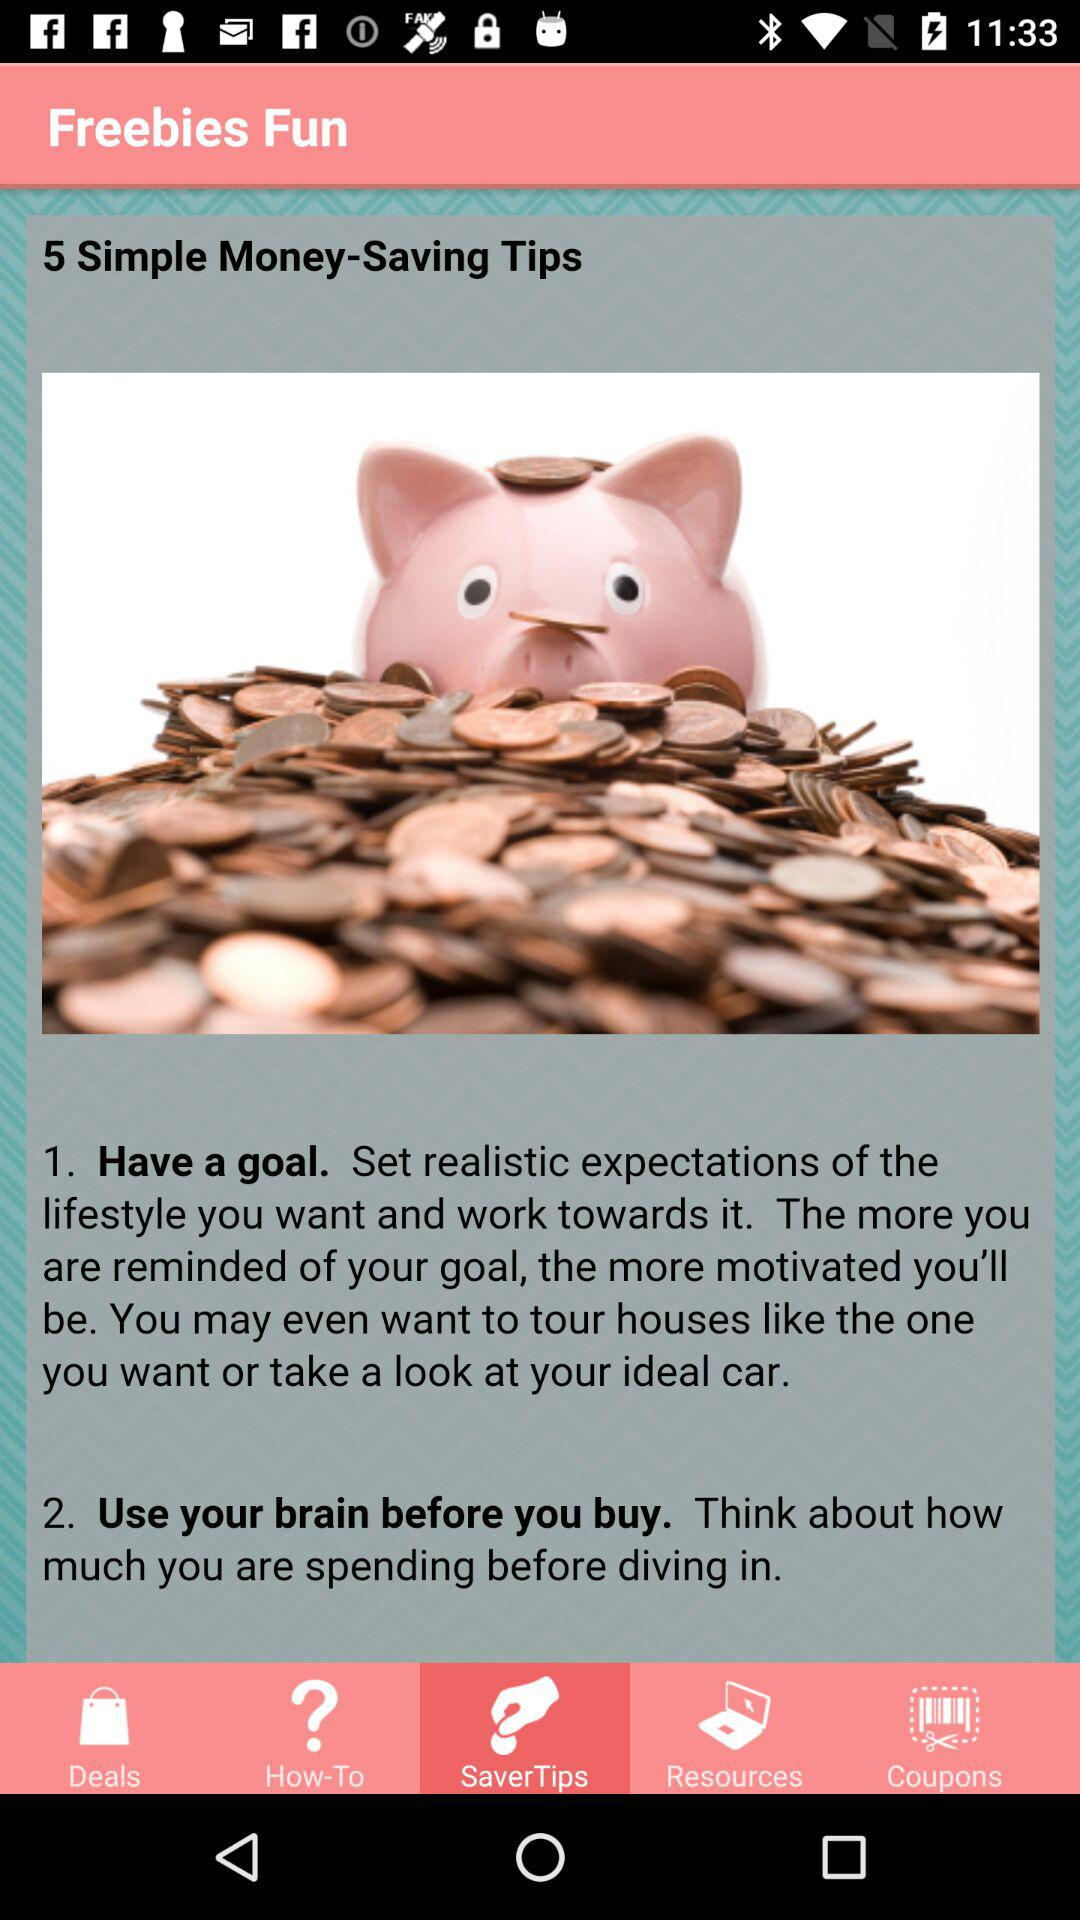Which tab am I now on? You are now on the "SaverTips" tab. 